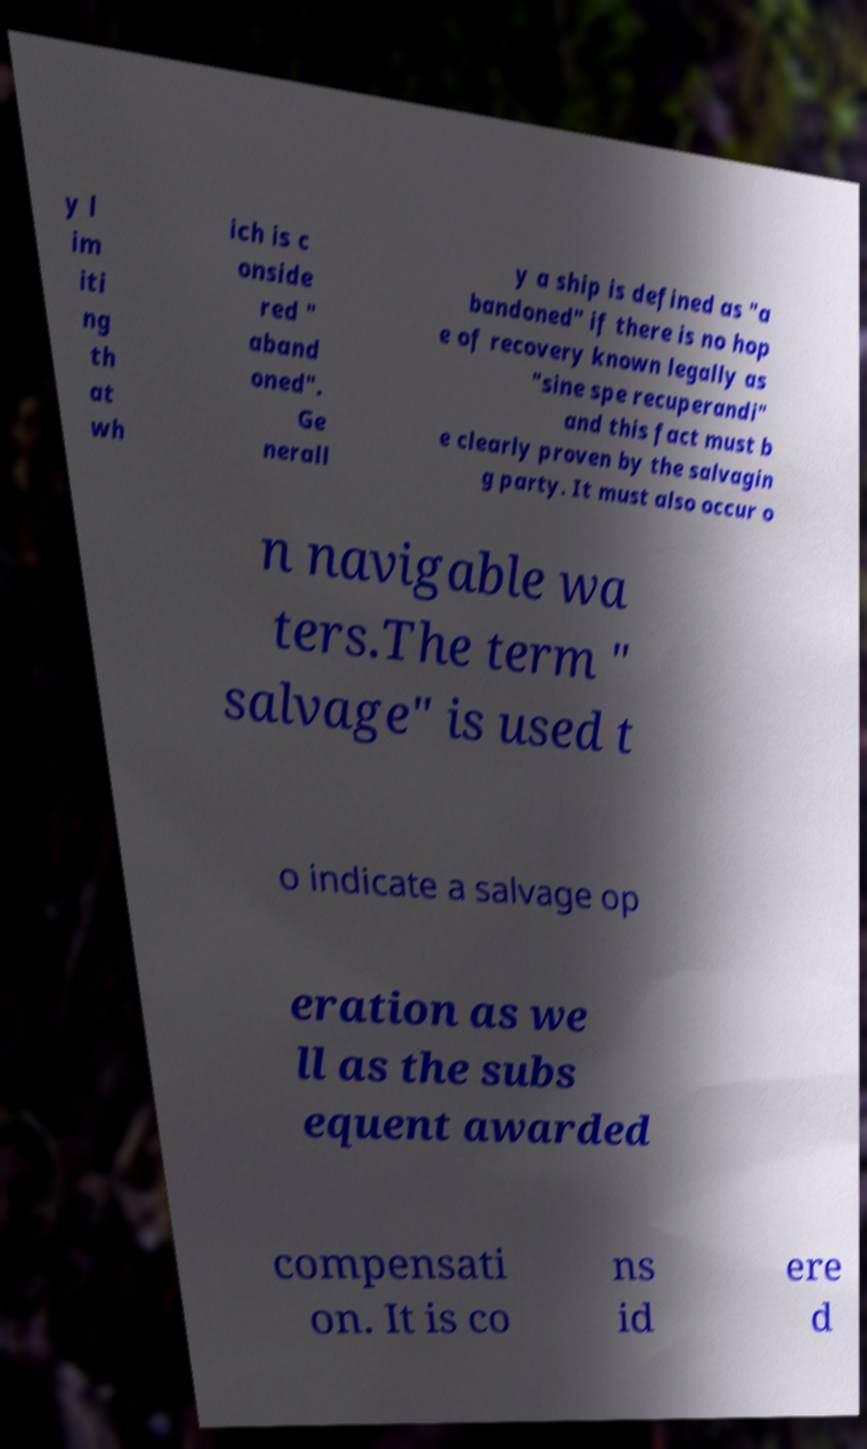Can you accurately transcribe the text from the provided image for me? y l im iti ng th at wh ich is c onside red " aband oned". Ge nerall y a ship is defined as "a bandoned" if there is no hop e of recovery known legally as "sine spe recuperandi" and this fact must b e clearly proven by the salvagin g party. It must also occur o n navigable wa ters.The term " salvage" is used t o indicate a salvage op eration as we ll as the subs equent awarded compensati on. It is co ns id ere d 